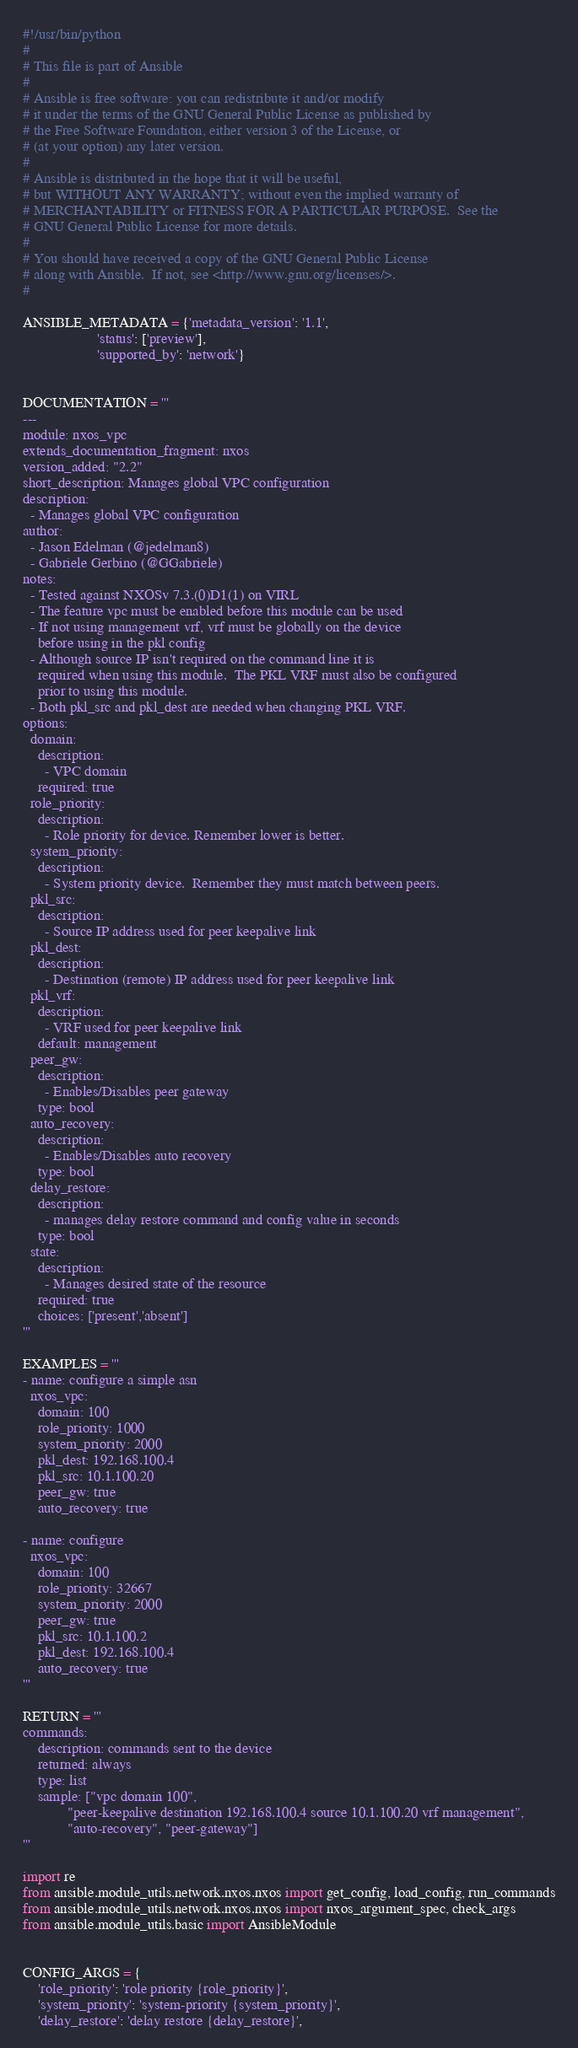<code> <loc_0><loc_0><loc_500><loc_500><_Python_>#!/usr/bin/python
#
# This file is part of Ansible
#
# Ansible is free software: you can redistribute it and/or modify
# it under the terms of the GNU General Public License as published by
# the Free Software Foundation, either version 3 of the License, or
# (at your option) any later version.
#
# Ansible is distributed in the hope that it will be useful,
# but WITHOUT ANY WARRANTY; without even the implied warranty of
# MERCHANTABILITY or FITNESS FOR A PARTICULAR PURPOSE.  See the
# GNU General Public License for more details.
#
# You should have received a copy of the GNU General Public License
# along with Ansible.  If not, see <http://www.gnu.org/licenses/>.
#

ANSIBLE_METADATA = {'metadata_version': '1.1',
                    'status': ['preview'],
                    'supported_by': 'network'}


DOCUMENTATION = '''
---
module: nxos_vpc
extends_documentation_fragment: nxos
version_added: "2.2"
short_description: Manages global VPC configuration
description:
  - Manages global VPC configuration
author:
  - Jason Edelman (@jedelman8)
  - Gabriele Gerbino (@GGabriele)
notes:
  - Tested against NXOSv 7.3.(0)D1(1) on VIRL
  - The feature vpc must be enabled before this module can be used
  - If not using management vrf, vrf must be globally on the device
    before using in the pkl config
  - Although source IP isn't required on the command line it is
    required when using this module.  The PKL VRF must also be configured
    prior to using this module.
  - Both pkl_src and pkl_dest are needed when changing PKL VRF.
options:
  domain:
    description:
      - VPC domain
    required: true
  role_priority:
    description:
      - Role priority for device. Remember lower is better.
  system_priority:
    description:
      - System priority device.  Remember they must match between peers.
  pkl_src:
    description:
      - Source IP address used for peer keepalive link
  pkl_dest:
    description:
      - Destination (remote) IP address used for peer keepalive link
  pkl_vrf:
    description:
      - VRF used for peer keepalive link
    default: management
  peer_gw:
    description:
      - Enables/Disables peer gateway
    type: bool
  auto_recovery:
    description:
      - Enables/Disables auto recovery
    type: bool
  delay_restore:
    description:
      - manages delay restore command and config value in seconds
    type: bool
  state:
    description:
      - Manages desired state of the resource
    required: true
    choices: ['present','absent']
'''

EXAMPLES = '''
- name: configure a simple asn
  nxos_vpc:
    domain: 100
    role_priority: 1000
    system_priority: 2000
    pkl_dest: 192.168.100.4
    pkl_src: 10.1.100.20
    peer_gw: true
    auto_recovery: true

- name: configure
  nxos_vpc:
    domain: 100
    role_priority: 32667
    system_priority: 2000
    peer_gw: true
    pkl_src: 10.1.100.2
    pkl_dest: 192.168.100.4
    auto_recovery: true
'''

RETURN = '''
commands:
    description: commands sent to the device
    returned: always
    type: list
    sample: ["vpc domain 100",
            "peer-keepalive destination 192.168.100.4 source 10.1.100.20 vrf management",
            "auto-recovery", "peer-gateway"]
'''

import re
from ansible.module_utils.network.nxos.nxos import get_config, load_config, run_commands
from ansible.module_utils.network.nxos.nxos import nxos_argument_spec, check_args
from ansible.module_utils.basic import AnsibleModule


CONFIG_ARGS = {
    'role_priority': 'role priority {role_priority}',
    'system_priority': 'system-priority {system_priority}',
    'delay_restore': 'delay restore {delay_restore}',</code> 